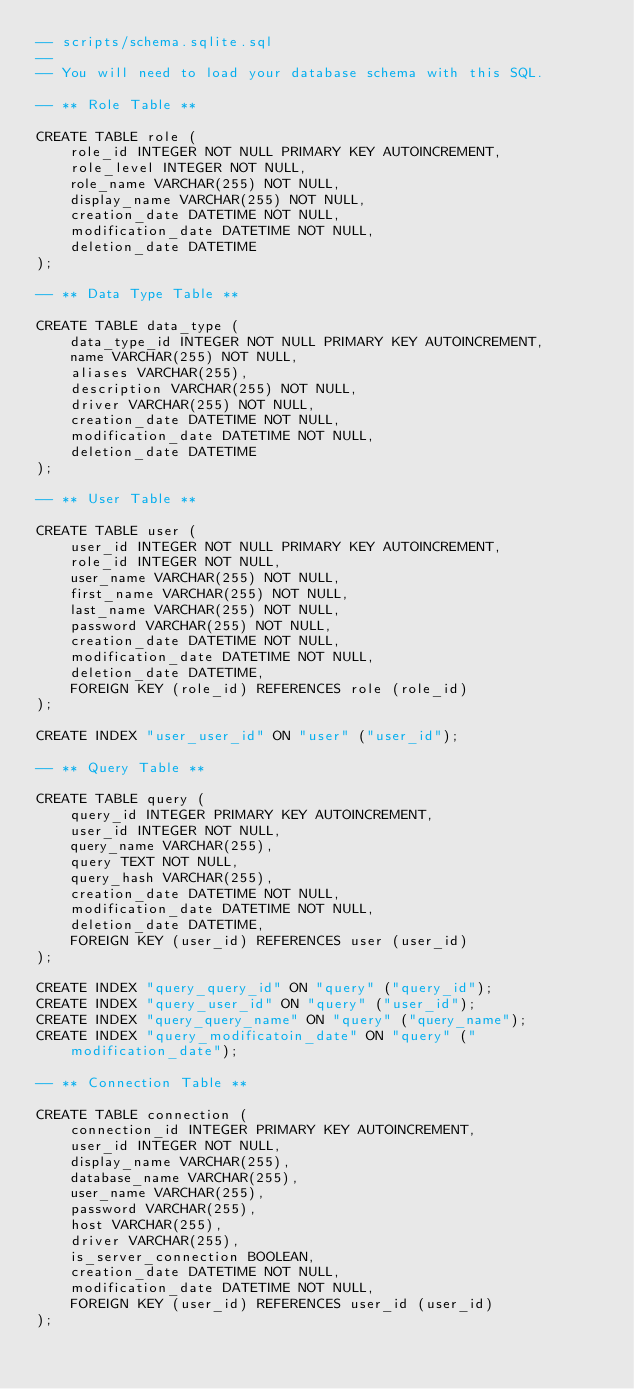<code> <loc_0><loc_0><loc_500><loc_500><_SQL_>-- scripts/schema.sqlite.sql
--
-- You will need to load your database schema with this SQL.

-- ** Role Table **

CREATE TABLE role (
    role_id INTEGER NOT NULL PRIMARY KEY AUTOINCREMENT,
    role_level INTEGER NOT NULL,
    role_name VARCHAR(255) NOT NULL,
    display_name VARCHAR(255) NOT NULL,
    creation_date DATETIME NOT NULL,
    modification_date DATETIME NOT NULL,
    deletion_date DATETIME
);

-- ** Data Type Table **

CREATE TABLE data_type (
    data_type_id INTEGER NOT NULL PRIMARY KEY AUTOINCREMENT,
    name VARCHAR(255) NOT NULL,
    aliases VARCHAR(255),
    description VARCHAR(255) NOT NULL,
    driver VARCHAR(255) NOT NULL,
    creation_date DATETIME NOT NULL,
    modification_date DATETIME NOT NULL,
    deletion_date DATETIME
);

-- ** User Table **

CREATE TABLE user (
    user_id INTEGER NOT NULL PRIMARY KEY AUTOINCREMENT,
    role_id INTEGER NOT NULL,
    user_name VARCHAR(255) NOT NULL,
    first_name VARCHAR(255) NOT NULL,
    last_name VARCHAR(255) NOT NULL,
    password VARCHAR(255) NOT NULL,
    creation_date DATETIME NOT NULL,
    modification_date DATETIME NOT NULL,
    deletion_date DATETIME,
    FOREIGN KEY (role_id) REFERENCES role (role_id)
);

CREATE INDEX "user_user_id" ON "user" ("user_id");

-- ** Query Table **

CREATE TABLE query (
    query_id INTEGER PRIMARY KEY AUTOINCREMENT,
    user_id INTEGER NOT NULL,
    query_name VARCHAR(255),
    query TEXT NOT NULL,
    query_hash VARCHAR(255),
    creation_date DATETIME NOT NULL,
    modification_date DATETIME NOT NULL,
    deletion_date DATETIME,
    FOREIGN KEY (user_id) REFERENCES user (user_id)
);

CREATE INDEX "query_query_id" ON "query" ("query_id");
CREATE INDEX "query_user_id" ON "query" ("user_id");
CREATE INDEX "query_query_name" ON "query" ("query_name");
CREATE INDEX "query_modificatoin_date" ON "query" ("modification_date");

-- ** Connection Table **

CREATE TABLE connection (
    connection_id INTEGER PRIMARY KEY AUTOINCREMENT,
    user_id INTEGER NOT NULL,
    display_name VARCHAR(255),
    database_name VARCHAR(255),
    user_name VARCHAR(255),
    password VARCHAR(255),
    host VARCHAR(255),
    driver VARCHAR(255),
    is_server_connection BOOLEAN,
    creation_date DATETIME NOT NULL,
    modification_date DATETIME NOT NULL,
    FOREIGN KEY (user_id) REFERENCES user_id (user_id)
);</code> 